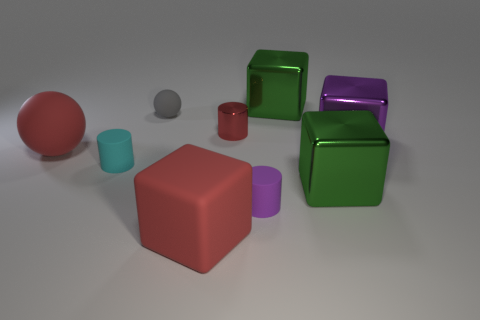What is the size of the red rubber object that is the same shape as the small gray thing?
Your answer should be very brief. Large. What is the color of the other matte object that is the same shape as the cyan thing?
Keep it short and to the point. Purple. There is a shiny thing in front of the big ball; how big is it?
Keep it short and to the point. Large. Is the number of purple cubes less than the number of tiny objects?
Keep it short and to the point. Yes. Is the small object behind the shiny cylinder made of the same material as the red thing that is on the right side of the large red rubber cube?
Keep it short and to the point. No. What is the shape of the red object that is in front of the small matte cylinder that is right of the tiny cyan cylinder that is on the left side of the small purple cylinder?
Give a very brief answer. Cube. How many other big things have the same material as the large purple object?
Give a very brief answer. 2. There is a large object that is behind the small rubber ball; how many large green metallic blocks are in front of it?
Ensure brevity in your answer.  1. Does the matte ball that is behind the tiny metallic cylinder have the same color as the tiny shiny cylinder behind the small cyan rubber cylinder?
Keep it short and to the point. No. There is a matte thing that is on the right side of the cyan rubber object and behind the cyan thing; what shape is it?
Keep it short and to the point. Sphere. 